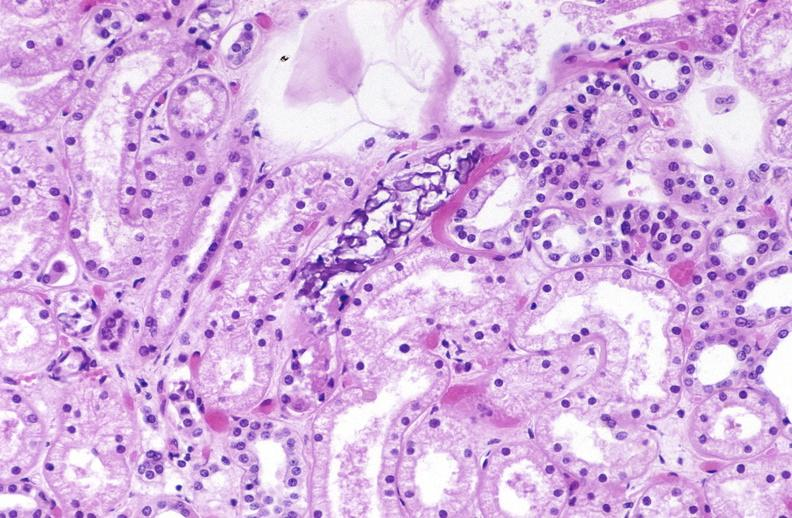where is this?
Answer the question using a single word or phrase. Urinary 